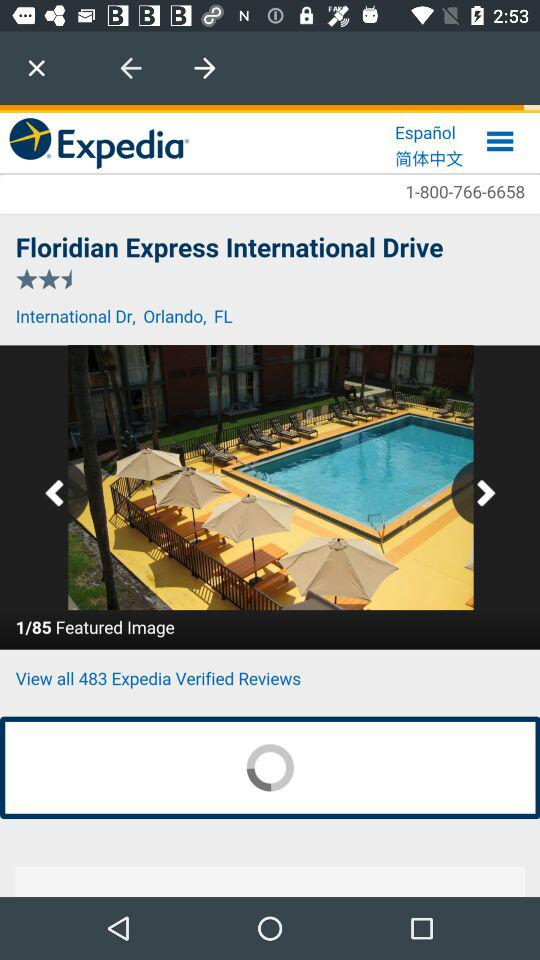What is the rating? The rating is 2.5 stars. 